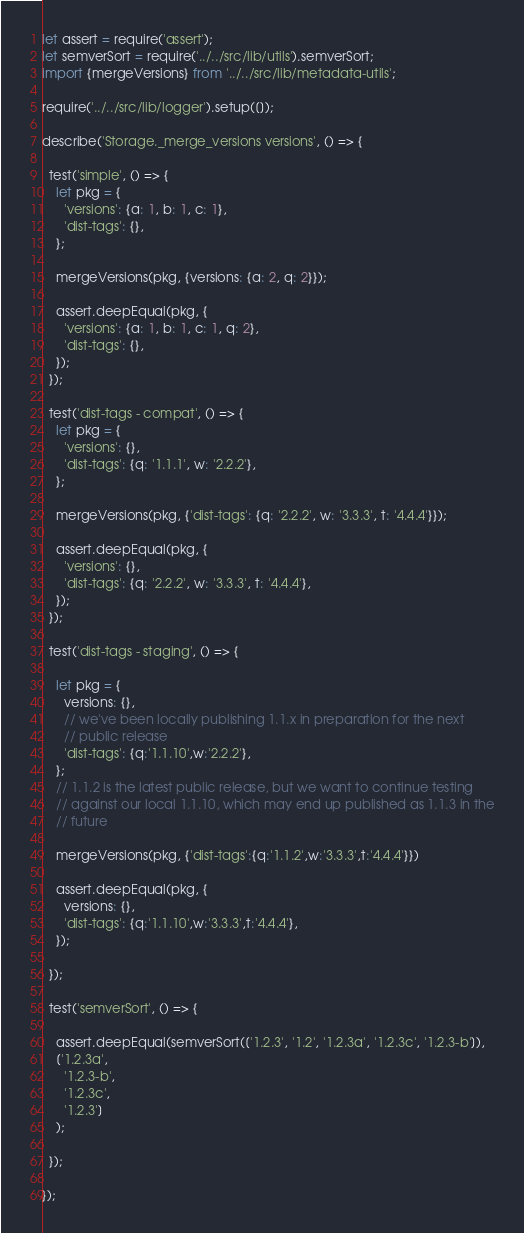Convert code to text. <code><loc_0><loc_0><loc_500><loc_500><_JavaScript_>let assert = require('assert');
let semverSort = require('../../src/lib/utils').semverSort;
import {mergeVersions} from '../../src/lib/metadata-utils';

require('../../src/lib/logger').setup([]);

describe('Storage._merge_versions versions', () => {

  test('simple', () => {
    let pkg = {
      'versions': {a: 1, b: 1, c: 1},
      'dist-tags': {},
    };

    mergeVersions(pkg, {versions: {a: 2, q: 2}});

    assert.deepEqual(pkg, {
      'versions': {a: 1, b: 1, c: 1, q: 2},
      'dist-tags': {},
    });
  });

  test('dist-tags - compat', () => {
    let pkg = {
      'versions': {},
      'dist-tags': {q: '1.1.1', w: '2.2.2'},
    };

    mergeVersions(pkg, {'dist-tags': {q: '2.2.2', w: '3.3.3', t: '4.4.4'}});

    assert.deepEqual(pkg, {
      'versions': {},
      'dist-tags': {q: '2.2.2', w: '3.3.3', t: '4.4.4'},
    });
  });

  test('dist-tags - staging', () => {

    let pkg = {
      versions: {},
      // we've been locally publishing 1.1.x in preparation for the next
      // public release
      'dist-tags': {q:'1.1.10',w:'2.2.2'},
    };
    // 1.1.2 is the latest public release, but we want to continue testing
    // against our local 1.1.10, which may end up published as 1.1.3 in the
    // future

    mergeVersions(pkg, {'dist-tags':{q:'1.1.2',w:'3.3.3',t:'4.4.4'}})

    assert.deepEqual(pkg, {
      versions: {},
      'dist-tags': {q:'1.1.10',w:'3.3.3',t:'4.4.4'},
    });

  });

  test('semverSort', () => {

    assert.deepEqual(semverSort(['1.2.3', '1.2', '1.2.3a', '1.2.3c', '1.2.3-b']),
    ['1.2.3a',
      '1.2.3-b',
      '1.2.3c',
      '1.2.3']
    );

  });

});

</code> 